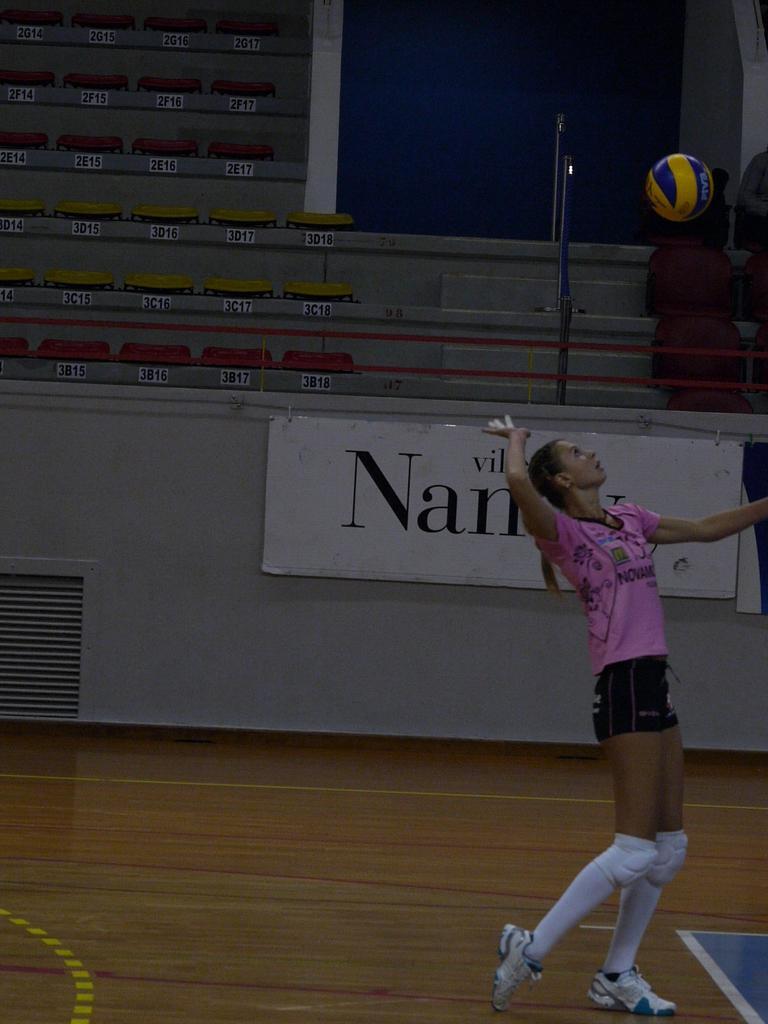In one or two sentences, can you explain what this image depicts? In this image there is one girl standing on the right side of this image and there is a floor in the bottom of this image ,and there is a wall in the background and there is a ball on the top right side of this image. 